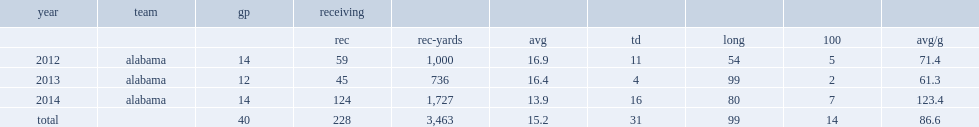In 2014, how many receptions did cooper have? 124.0. 